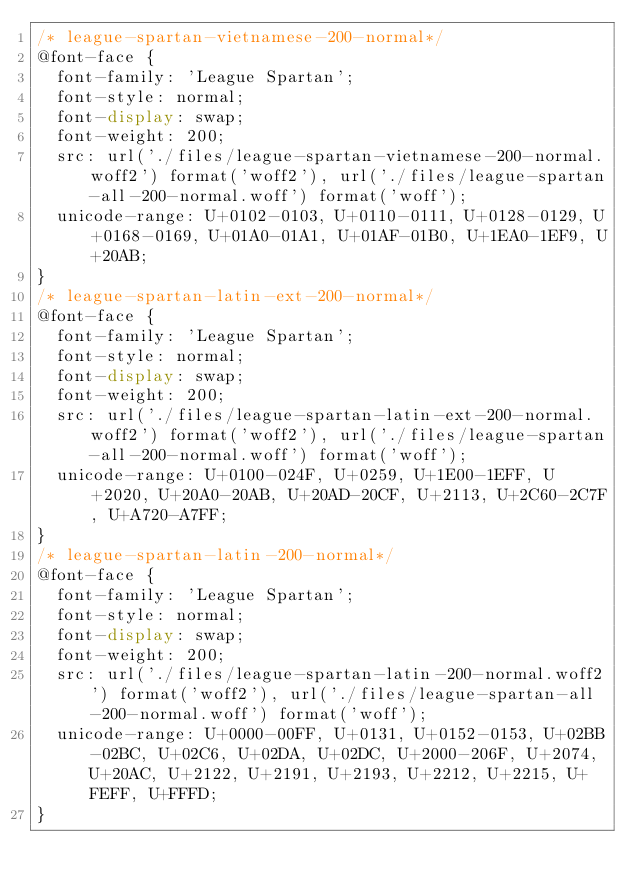Convert code to text. <code><loc_0><loc_0><loc_500><loc_500><_CSS_>/* league-spartan-vietnamese-200-normal*/
@font-face {
  font-family: 'League Spartan';
  font-style: normal;
  font-display: swap;
  font-weight: 200;
  src: url('./files/league-spartan-vietnamese-200-normal.woff2') format('woff2'), url('./files/league-spartan-all-200-normal.woff') format('woff');
  unicode-range: U+0102-0103, U+0110-0111, U+0128-0129, U+0168-0169, U+01A0-01A1, U+01AF-01B0, U+1EA0-1EF9, U+20AB;
}
/* league-spartan-latin-ext-200-normal*/
@font-face {
  font-family: 'League Spartan';
  font-style: normal;
  font-display: swap;
  font-weight: 200;
  src: url('./files/league-spartan-latin-ext-200-normal.woff2') format('woff2'), url('./files/league-spartan-all-200-normal.woff') format('woff');
  unicode-range: U+0100-024F, U+0259, U+1E00-1EFF, U+2020, U+20A0-20AB, U+20AD-20CF, U+2113, U+2C60-2C7F, U+A720-A7FF;
}
/* league-spartan-latin-200-normal*/
@font-face {
  font-family: 'League Spartan';
  font-style: normal;
  font-display: swap;
  font-weight: 200;
  src: url('./files/league-spartan-latin-200-normal.woff2') format('woff2'), url('./files/league-spartan-all-200-normal.woff') format('woff');
  unicode-range: U+0000-00FF, U+0131, U+0152-0153, U+02BB-02BC, U+02C6, U+02DA, U+02DC, U+2000-206F, U+2074, U+20AC, U+2122, U+2191, U+2193, U+2212, U+2215, U+FEFF, U+FFFD;
}
</code> 